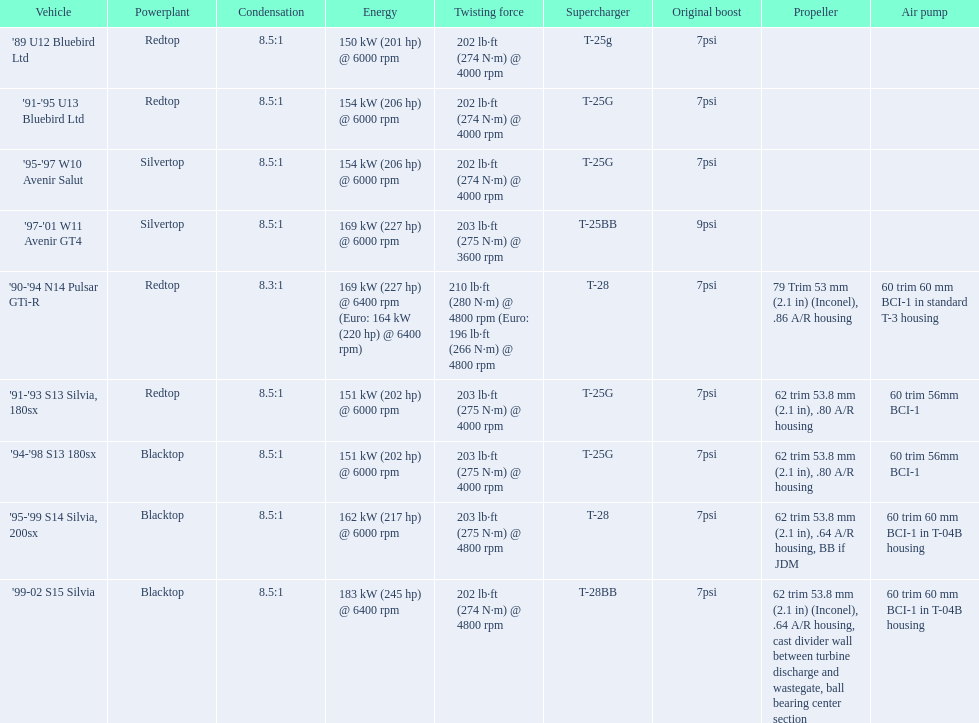What are all of the nissan cars? '89 U12 Bluebird Ltd, '91-'95 U13 Bluebird Ltd, '95-'97 W10 Avenir Salut, '97-'01 W11 Avenir GT4, '90-'94 N14 Pulsar GTi-R, '91-'93 S13 Silvia, 180sx, '94-'98 S13 180sx, '95-'99 S14 Silvia, 200sx, '99-02 S15 Silvia. Of these cars, which one is a '90-'94 n14 pulsar gti-r? '90-'94 N14 Pulsar GTi-R. What is the compression of this car? 8.3:1. 